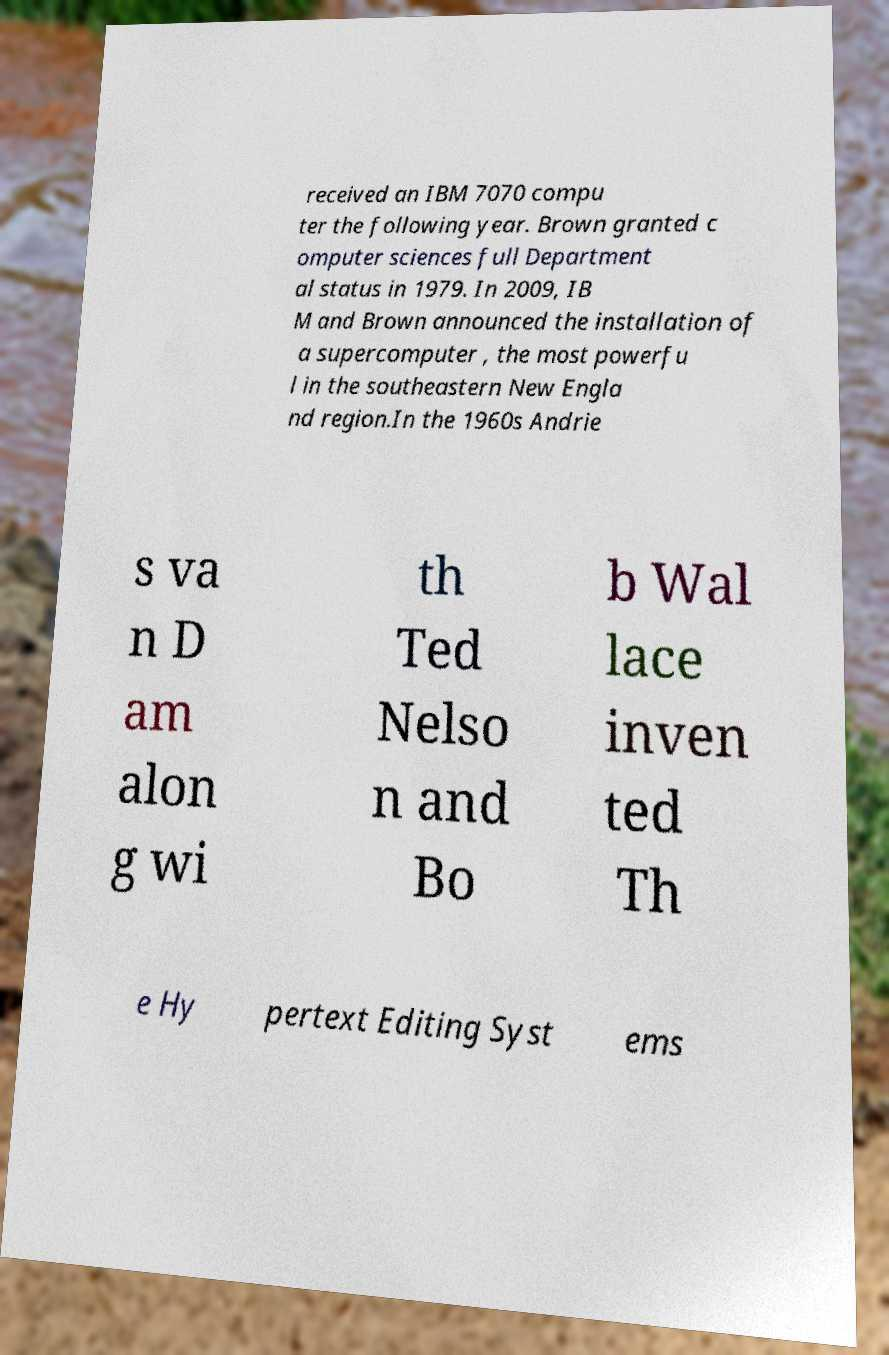Could you assist in decoding the text presented in this image and type it out clearly? received an IBM 7070 compu ter the following year. Brown granted c omputer sciences full Department al status in 1979. In 2009, IB M and Brown announced the installation of a supercomputer , the most powerfu l in the southeastern New Engla nd region.In the 1960s Andrie s va n D am alon g wi th Ted Nelso n and Bo b Wal lace inven ted Th e Hy pertext Editing Syst ems 